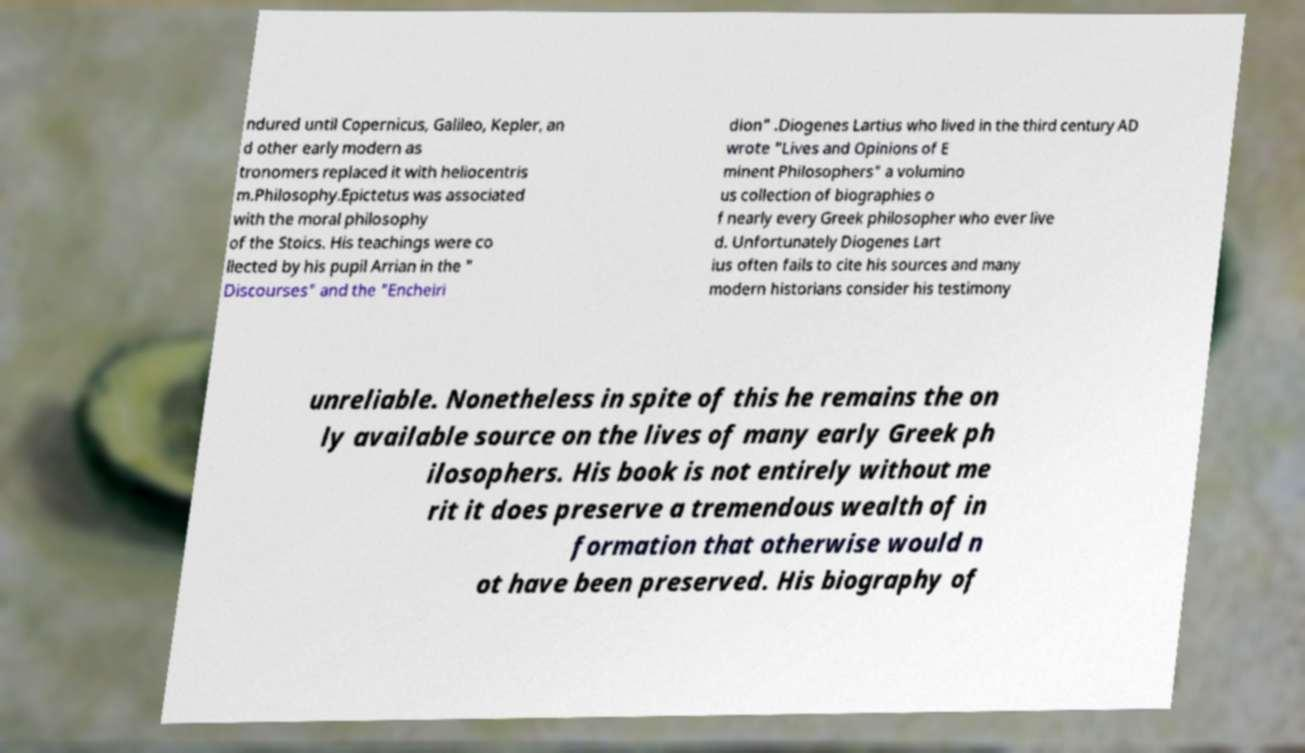Could you assist in decoding the text presented in this image and type it out clearly? ndured until Copernicus, Galileo, Kepler, an d other early modern as tronomers replaced it with heliocentris m.Philosophy.Epictetus was associated with the moral philosophy of the Stoics. His teachings were co llected by his pupil Arrian in the " Discourses" and the "Encheiri dion" .Diogenes Lartius who lived in the third century AD wrote "Lives and Opinions of E minent Philosophers" a volumino us collection of biographies o f nearly every Greek philosopher who ever live d. Unfortunately Diogenes Lart ius often fails to cite his sources and many modern historians consider his testimony unreliable. Nonetheless in spite of this he remains the on ly available source on the lives of many early Greek ph ilosophers. His book is not entirely without me rit it does preserve a tremendous wealth of in formation that otherwise would n ot have been preserved. His biography of 